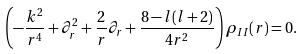Convert formula to latex. <formula><loc_0><loc_0><loc_500><loc_500>\left ( - \frac { k ^ { 2 } } { r ^ { 4 } } + \partial _ { r } ^ { 2 } + \frac { 2 } { r } \partial _ { r } + \frac { 8 - l ( l + 2 ) } { 4 r ^ { 2 } } \right ) \rho _ { I I } ( r ) = 0 .</formula> 